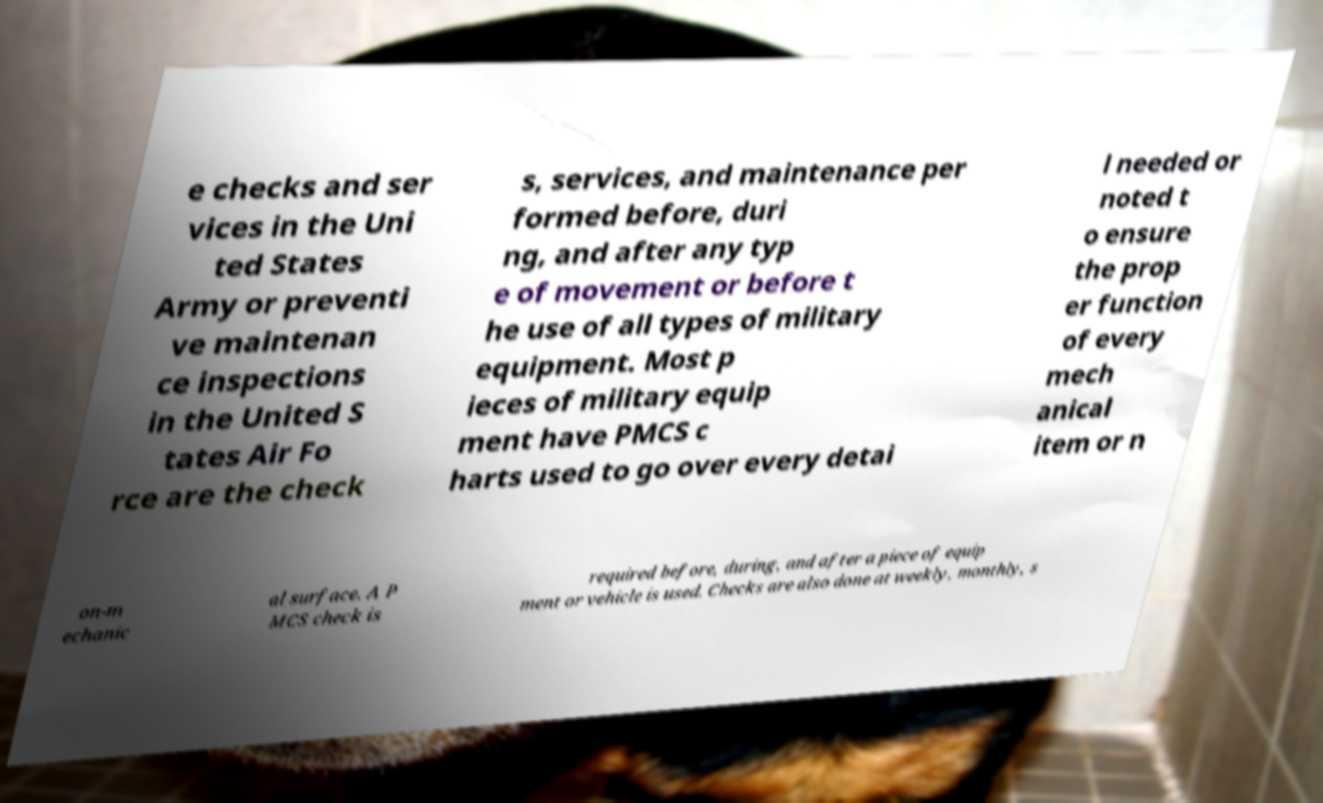There's text embedded in this image that I need extracted. Can you transcribe it verbatim? e checks and ser vices in the Uni ted States Army or preventi ve maintenan ce inspections in the United S tates Air Fo rce are the check s, services, and maintenance per formed before, duri ng, and after any typ e of movement or before t he use of all types of military equipment. Most p ieces of military equip ment have PMCS c harts used to go over every detai l needed or noted t o ensure the prop er function of every mech anical item or n on-m echanic al surface. A P MCS check is required before, during, and after a piece of equip ment or vehicle is used. Checks are also done at weekly, monthly, s 